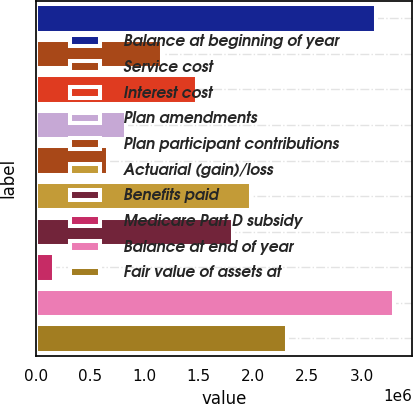<chart> <loc_0><loc_0><loc_500><loc_500><bar_chart><fcel>Balance at beginning of year<fcel>Service cost<fcel>Interest cost<fcel>Plan amendments<fcel>Plan participant contributions<fcel>Actuarial (gain)/loss<fcel>Benefits paid<fcel>Medicare Part D subsidy<fcel>Balance at end of year<fcel>Fair value of assets at<nl><fcel>3.1372e+06<fcel>1.15743e+06<fcel>1.48739e+06<fcel>827463<fcel>662482<fcel>1.98233e+06<fcel>1.81735e+06<fcel>167538<fcel>3.30218e+06<fcel>2.31229e+06<nl></chart> 